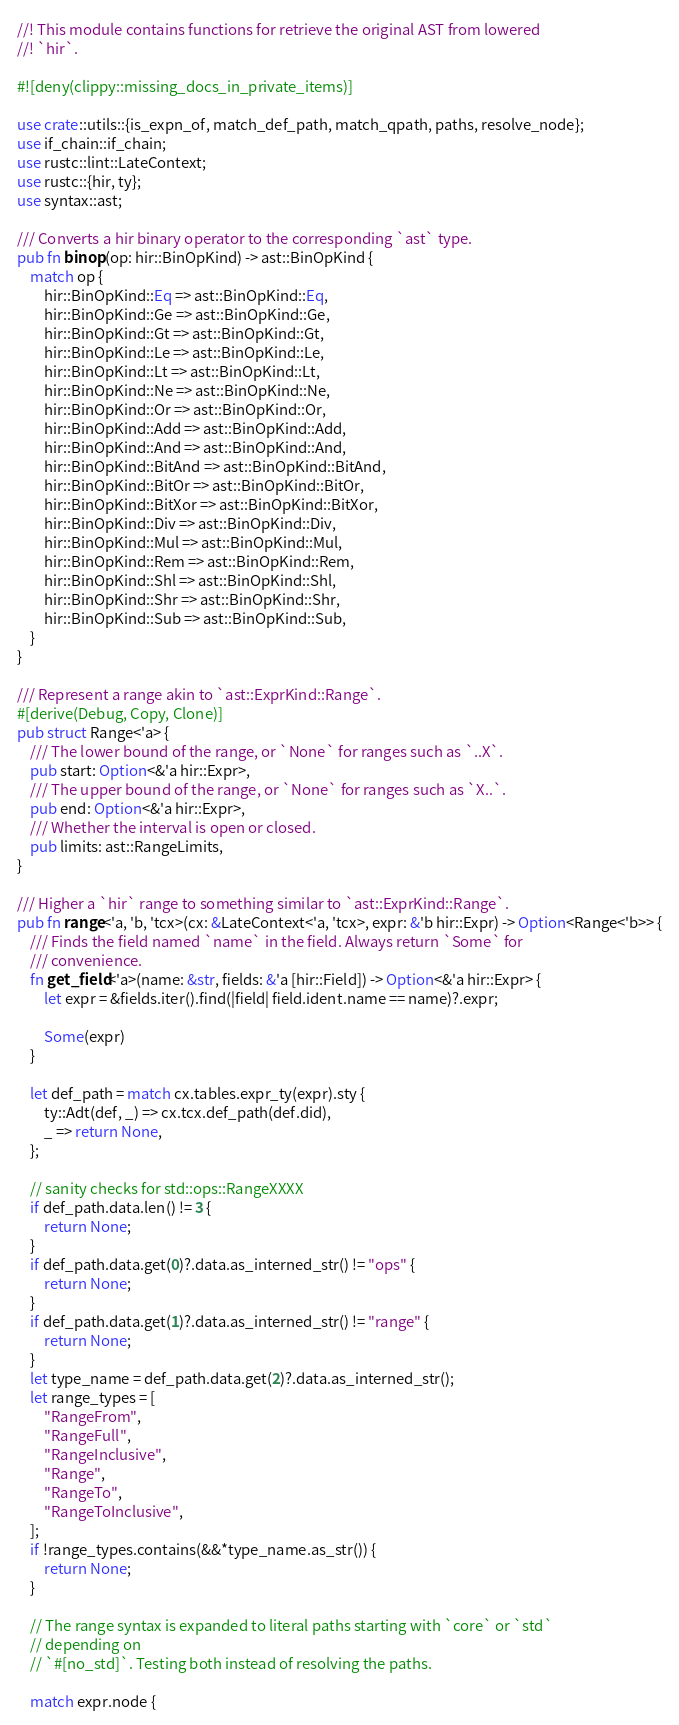Convert code to text. <code><loc_0><loc_0><loc_500><loc_500><_Rust_>//! This module contains functions for retrieve the original AST from lowered
//! `hir`.

#![deny(clippy::missing_docs_in_private_items)]

use crate::utils::{is_expn_of, match_def_path, match_qpath, paths, resolve_node};
use if_chain::if_chain;
use rustc::lint::LateContext;
use rustc::{hir, ty};
use syntax::ast;

/// Converts a hir binary operator to the corresponding `ast` type.
pub fn binop(op: hir::BinOpKind) -> ast::BinOpKind {
    match op {
        hir::BinOpKind::Eq => ast::BinOpKind::Eq,
        hir::BinOpKind::Ge => ast::BinOpKind::Ge,
        hir::BinOpKind::Gt => ast::BinOpKind::Gt,
        hir::BinOpKind::Le => ast::BinOpKind::Le,
        hir::BinOpKind::Lt => ast::BinOpKind::Lt,
        hir::BinOpKind::Ne => ast::BinOpKind::Ne,
        hir::BinOpKind::Or => ast::BinOpKind::Or,
        hir::BinOpKind::Add => ast::BinOpKind::Add,
        hir::BinOpKind::And => ast::BinOpKind::And,
        hir::BinOpKind::BitAnd => ast::BinOpKind::BitAnd,
        hir::BinOpKind::BitOr => ast::BinOpKind::BitOr,
        hir::BinOpKind::BitXor => ast::BinOpKind::BitXor,
        hir::BinOpKind::Div => ast::BinOpKind::Div,
        hir::BinOpKind::Mul => ast::BinOpKind::Mul,
        hir::BinOpKind::Rem => ast::BinOpKind::Rem,
        hir::BinOpKind::Shl => ast::BinOpKind::Shl,
        hir::BinOpKind::Shr => ast::BinOpKind::Shr,
        hir::BinOpKind::Sub => ast::BinOpKind::Sub,
    }
}

/// Represent a range akin to `ast::ExprKind::Range`.
#[derive(Debug, Copy, Clone)]
pub struct Range<'a> {
    /// The lower bound of the range, or `None` for ranges such as `..X`.
    pub start: Option<&'a hir::Expr>,
    /// The upper bound of the range, or `None` for ranges such as `X..`.
    pub end: Option<&'a hir::Expr>,
    /// Whether the interval is open or closed.
    pub limits: ast::RangeLimits,
}

/// Higher a `hir` range to something similar to `ast::ExprKind::Range`.
pub fn range<'a, 'b, 'tcx>(cx: &LateContext<'a, 'tcx>, expr: &'b hir::Expr) -> Option<Range<'b>> {
    /// Finds the field named `name` in the field. Always return `Some` for
    /// convenience.
    fn get_field<'a>(name: &str, fields: &'a [hir::Field]) -> Option<&'a hir::Expr> {
        let expr = &fields.iter().find(|field| field.ident.name == name)?.expr;

        Some(expr)
    }

    let def_path = match cx.tables.expr_ty(expr).sty {
        ty::Adt(def, _) => cx.tcx.def_path(def.did),
        _ => return None,
    };

    // sanity checks for std::ops::RangeXXXX
    if def_path.data.len() != 3 {
        return None;
    }
    if def_path.data.get(0)?.data.as_interned_str() != "ops" {
        return None;
    }
    if def_path.data.get(1)?.data.as_interned_str() != "range" {
        return None;
    }
    let type_name = def_path.data.get(2)?.data.as_interned_str();
    let range_types = [
        "RangeFrom",
        "RangeFull",
        "RangeInclusive",
        "Range",
        "RangeTo",
        "RangeToInclusive",
    ];
    if !range_types.contains(&&*type_name.as_str()) {
        return None;
    }

    // The range syntax is expanded to literal paths starting with `core` or `std`
    // depending on
    // `#[no_std]`. Testing both instead of resolving the paths.

    match expr.node {</code> 